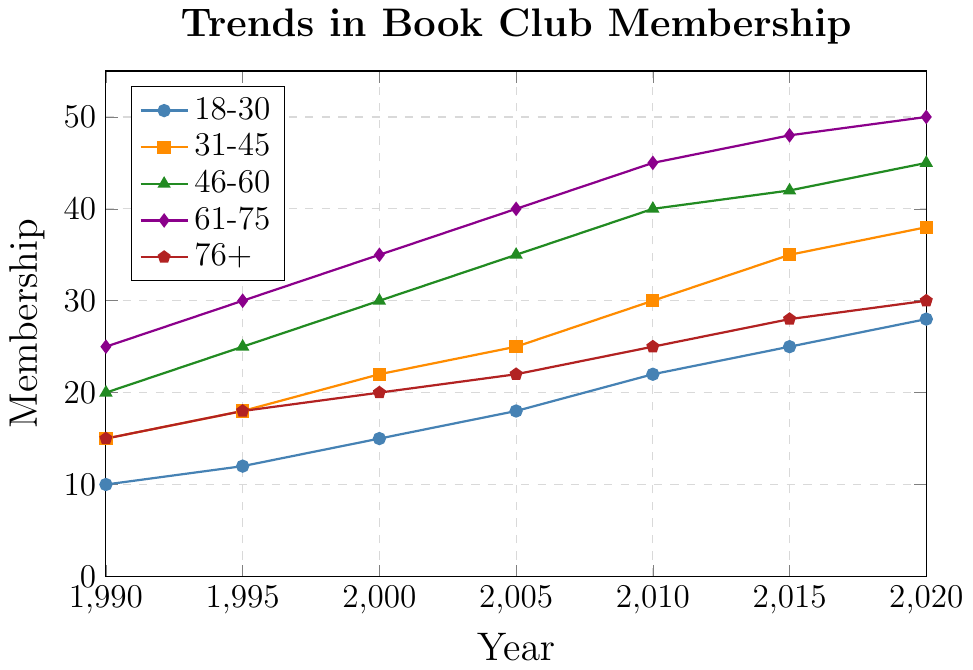What was the membership count for the 18-30 age group in 2010? Find the point on the line representing the 18-30 age group (blue line with circular markers) corresponding to the year 2010 on the x-axis, which is (2010, 22).
Answer: 22 Which age group had the highest membership count in 2020? Look at the endpoints of all the lines for the year 2020 on the x-axis. The highest point is on the purple line with diamond markers representing the 61-75 age group at 50.
Answer: 61-75 Between 2000 and 2010, which age group saw the largest increase in membership? Calculate the increase for each age group between 2000 and 2010. For 18-30: 22-15 = 7, 31-45: 30-22 = 8, 46-60: 40-30 = 10, 61-75: 45-35 = 10, 76+: 25-20 = 5. The largest increase, 10, is seen in the 46-60 and 61-75 age groups.
Answer: 46-60 and 61-75 Which age group's membership grew more between 1995 to 2000, the 18-30 or the 76+ group? Calculate the growth for both age groups: 18-30: 15-12 = 3, 76+: 20-18 = 2. The 18-30 age group had more growth with an increase of 3 members.
Answer: 18-30 What is the average membership count for the 61-75 age group across all years? Sum the membership counts from 1990 to 2020 for the 61-75 group and divide by the number of years: (25+30+35+40+45+48+50)/7. Sum is 273, so the average is 273/7 = 39.
Answer: 39 Is the membership count for 31-45 age group higher than for 76+ age group in 1995? Compare the membership counts for the year 1995 on the x-axis for the age groups 31-45 (orange line, 18) and 76+ (red line, 18). Both have the same membership count.
Answer: No, they are equal Which age group had the smallest growth in membership from 1990 to 2020? Calculate the overall growth for each age group by subtracting their 1990 membership count from their 2020 count. 18-30: 28-10 = 18, 31-45: 38-15 = 23, 46-60: 45-20 = 25, 61-75: 50-25 = 25, 76+: 30-15 = 15. The smallest growth is 15 for the 76+ group.
Answer: 76+ In which decade did the 46-60 age group experience the steepest increase in membership? Compare the increases in each decade for the 46-60 age group. 1990-2000: 30-20 = 10, 2000-2010: 40-30 = 10, 2010-2020: 45-40 = 5. The steepest increase occurred in both decades 1990-2000 and 2000-2010.
Answer: 1990-2000 and 2000-2010 